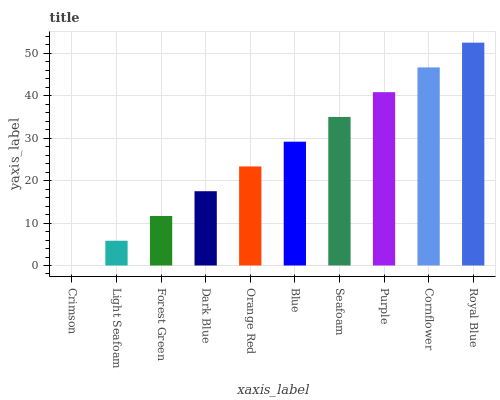Is Crimson the minimum?
Answer yes or no. Yes. Is Royal Blue the maximum?
Answer yes or no. Yes. Is Light Seafoam the minimum?
Answer yes or no. No. Is Light Seafoam the maximum?
Answer yes or no. No. Is Light Seafoam greater than Crimson?
Answer yes or no. Yes. Is Crimson less than Light Seafoam?
Answer yes or no. Yes. Is Crimson greater than Light Seafoam?
Answer yes or no. No. Is Light Seafoam less than Crimson?
Answer yes or no. No. Is Blue the high median?
Answer yes or no. Yes. Is Orange Red the low median?
Answer yes or no. Yes. Is Dark Blue the high median?
Answer yes or no. No. Is Cornflower the low median?
Answer yes or no. No. 